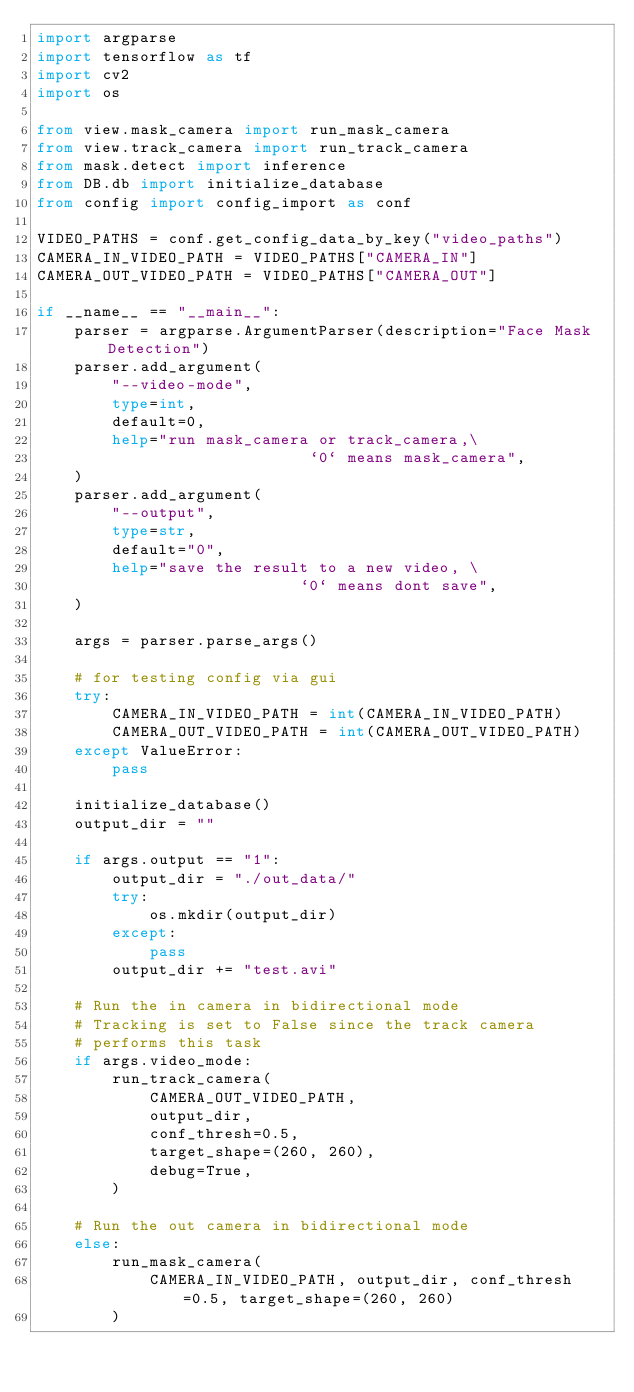<code> <loc_0><loc_0><loc_500><loc_500><_Python_>import argparse
import tensorflow as tf
import cv2
import os

from view.mask_camera import run_mask_camera
from view.track_camera import run_track_camera
from mask.detect import inference
from DB.db import initialize_database
from config import config_import as conf

VIDEO_PATHS = conf.get_config_data_by_key("video_paths")
CAMERA_IN_VIDEO_PATH = VIDEO_PATHS["CAMERA_IN"]
CAMERA_OUT_VIDEO_PATH = VIDEO_PATHS["CAMERA_OUT"]

if __name__ == "__main__":
    parser = argparse.ArgumentParser(description="Face Mask Detection")
    parser.add_argument(
        "--video-mode",
        type=int,
        default=0,
        help="run mask_camera or track_camera,\
                             `0` means mask_camera",
    )
    parser.add_argument(
        "--output",
        type=str,
        default="0",
        help="save the result to a new video, \
                            `0` means dont save",
    )

    args = parser.parse_args()

    # for testing config via gui
    try:
        CAMERA_IN_VIDEO_PATH = int(CAMERA_IN_VIDEO_PATH)
        CAMERA_OUT_VIDEO_PATH = int(CAMERA_OUT_VIDEO_PATH)
    except ValueError:
        pass

    initialize_database()
    output_dir = ""

    if args.output == "1":
        output_dir = "./out_data/"
        try:
            os.mkdir(output_dir)
        except:
            pass
        output_dir += "test.avi"

    # Run the in camera in bidirectional mode
    # Tracking is set to False since the track camera
    # performs this task
    if args.video_mode:
        run_track_camera(
            CAMERA_OUT_VIDEO_PATH,
            output_dir,
            conf_thresh=0.5,
            target_shape=(260, 260),
            debug=True,
        )

    # Run the out camera in bidirectional mode
    else:
        run_mask_camera(
            CAMERA_IN_VIDEO_PATH, output_dir, conf_thresh=0.5, target_shape=(260, 260)
        )
</code> 